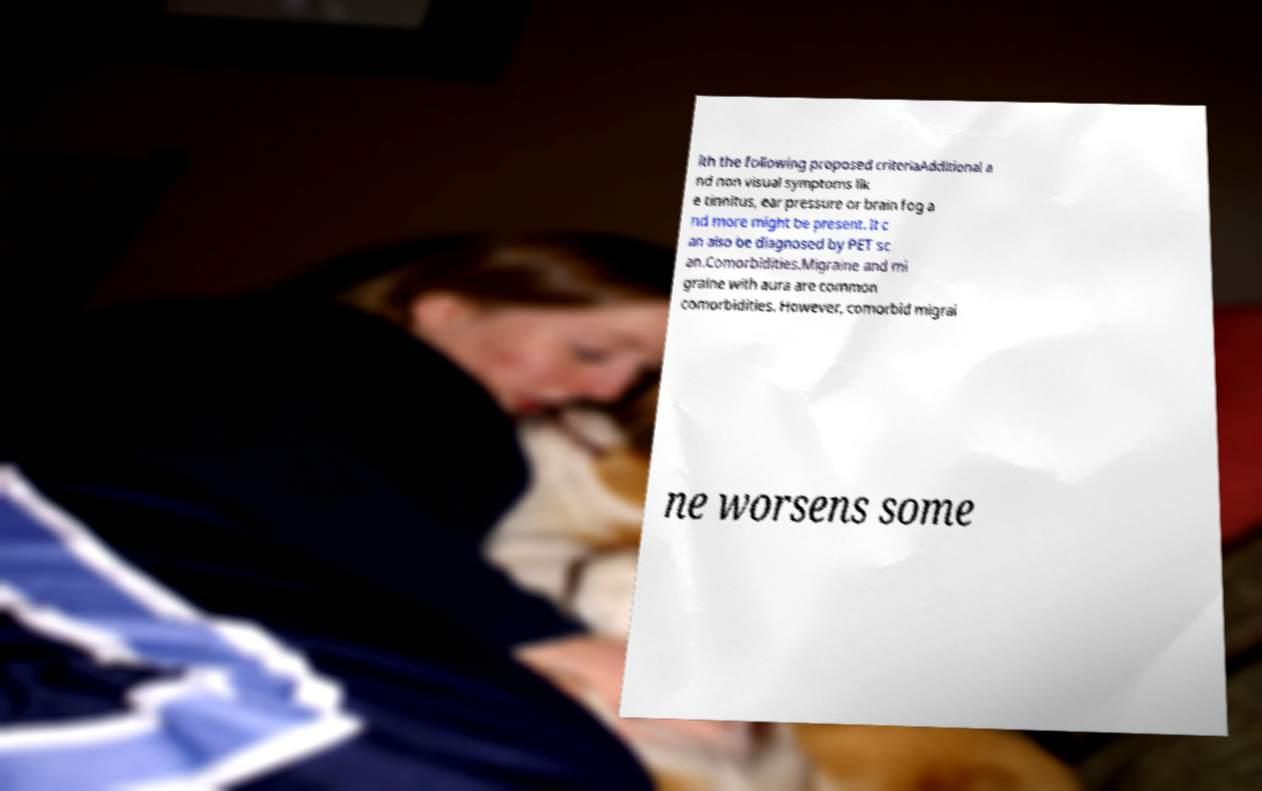I need the written content from this picture converted into text. Can you do that? ith the following proposed criteriaAdditional a nd non visual symptoms lik e tinnitus, ear pressure or brain fog a nd more might be present. It c an also be diagnosed by PET sc an.Comorbidities.Migraine and mi graine with aura are common comorbidities. However, comorbid migrai ne worsens some 